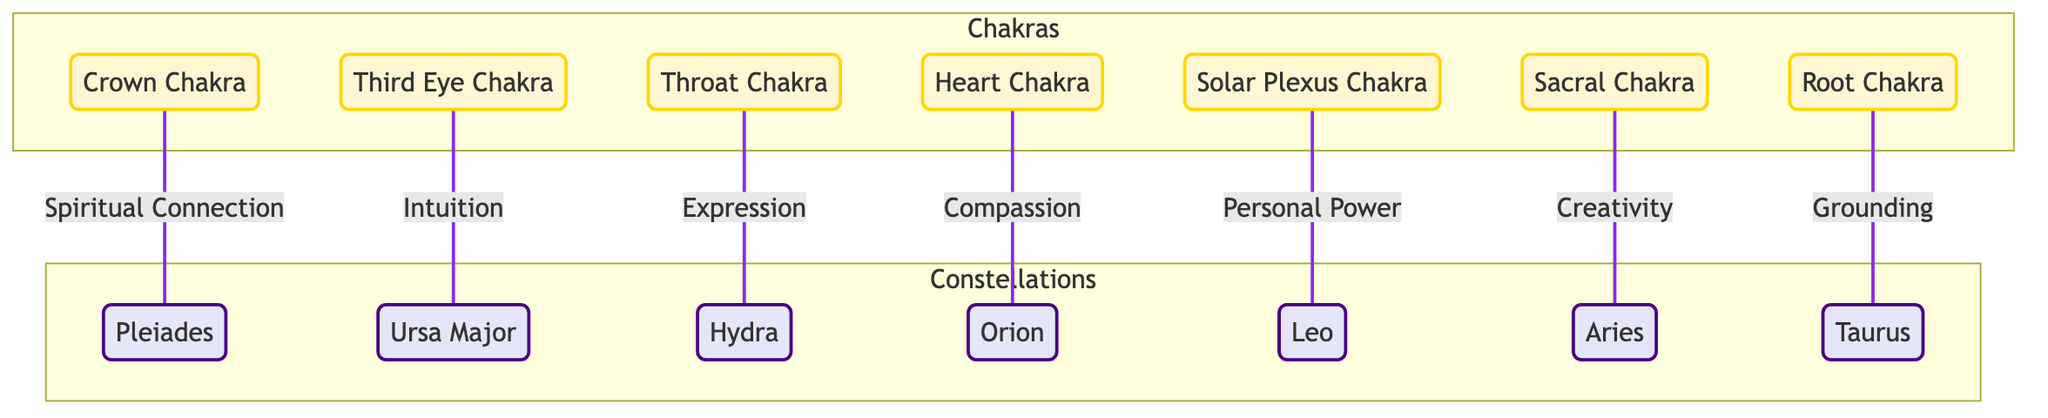What is the connection between the Crown Chakra and the Pleiades? The diagram indicates that there is a "Spiritual Connection" between the Crown Chakra and the Pleiades, which is represented through a directed relationship that shows this connection specifically.
Answer: Spiritual Connection How many chakras are represented in the diagram? The diagram visually displays a total of seven distinct chakras, which are listed within a specific subgraph section labeled "Chakras."
Answer: 7 Which chakra correlates with the constellation Orion? According to the diagram, the Heart Chakra is linked to the constellation Orion through a relationship labeled "Compassion." This connection shows how they are paired in the context of energetic connections.
Answer: Heart Chakra What does the Solar Plexus Chakra represent in this diagram? The Solar Plexus Chakra is connected to the constellation Leo, indicating that it represents "Personal Power," which is noted explicitly in the relationship depicted in the diagram.
Answer: Personal Power Which two constellations are connected by the Sacral Chakra? The diagram illustrates that the Sacral Chakra is associated with the constellation Aries, but does not connect it to any other constellation. Therefore, the only constellation specifically linked is Aries.
Answer: Aries How many connections are shown from chakras to constellations in this diagram? The diagram illustrates a total of seven distinct connections from each of the seven chakras to their corresponding constellations, as depicted by the lines connecting them in a one-to-one relationship.
Answer: 7 What is the relationship linked to the Third Eye Chakra? The diagram specifies that the Third Eye Chakra is associated with intuition, which is highlighted as the nature of the connection with the Ursa Major constellation. This context clarifies what the chakra signifies in this dynamic.
Answer: Intuition Which chakra is related to grounding? The Root Chakra is the one indicated in the diagram as having a connection associated with "Grounding," which is linked specifically to the Taurus constellation as part of the energetic mapping being illustrated.
Answer: Root Chakra What color represents the chakras in the diagram? The chakras in the diagram are highlighted with a fill color of "#FFF7D4," indicating that they share a soft yellow hue throughout their visual representation.
Answer: #FFF7D4 